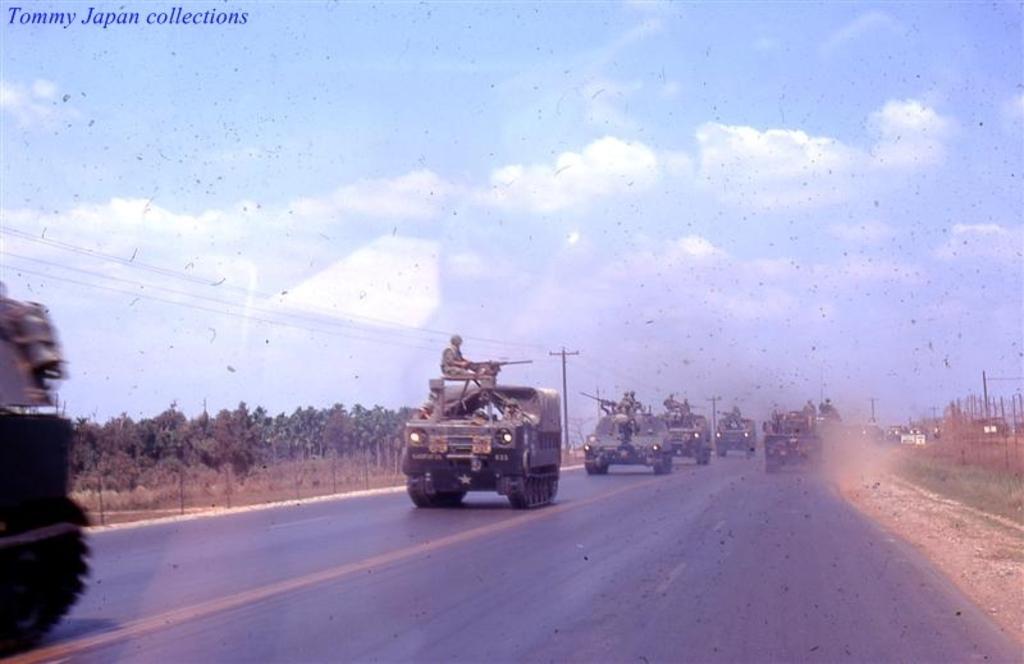Describe this image in one or two sentences. In this image we can see some vehicles on the road. We can also see some people sitting inside it. On the backside we can see a group of trees, a fence, utility poles with wires and the sky which looks cloudy. 